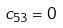Convert formula to latex. <formula><loc_0><loc_0><loc_500><loc_500>c _ { 5 3 } = 0</formula> 